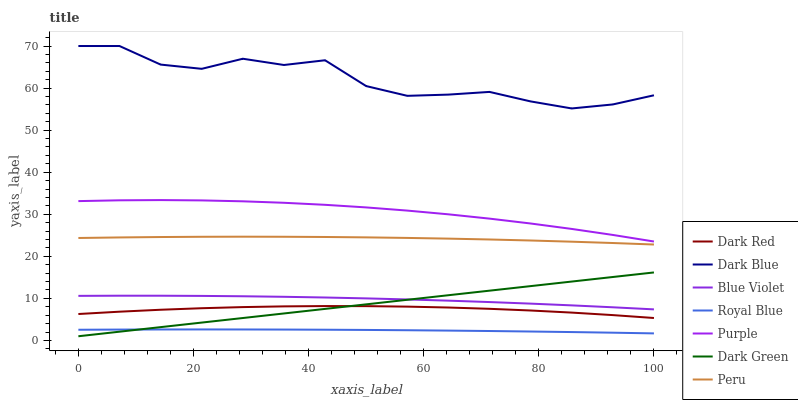Does Royal Blue have the minimum area under the curve?
Answer yes or no. Yes. Does Dark Blue have the maximum area under the curve?
Answer yes or no. Yes. Does Purple have the minimum area under the curve?
Answer yes or no. No. Does Purple have the maximum area under the curve?
Answer yes or no. No. Is Dark Green the smoothest?
Answer yes or no. Yes. Is Dark Blue the roughest?
Answer yes or no. Yes. Is Purple the smoothest?
Answer yes or no. No. Is Purple the roughest?
Answer yes or no. No. Does Purple have the lowest value?
Answer yes or no. No. Does Dark Blue have the highest value?
Answer yes or no. Yes. Does Purple have the highest value?
Answer yes or no. No. Is Peru less than Dark Blue?
Answer yes or no. Yes. Is Peru greater than Dark Green?
Answer yes or no. Yes. Does Royal Blue intersect Dark Green?
Answer yes or no. Yes. Is Royal Blue less than Dark Green?
Answer yes or no. No. Is Royal Blue greater than Dark Green?
Answer yes or no. No. Does Peru intersect Dark Blue?
Answer yes or no. No. 